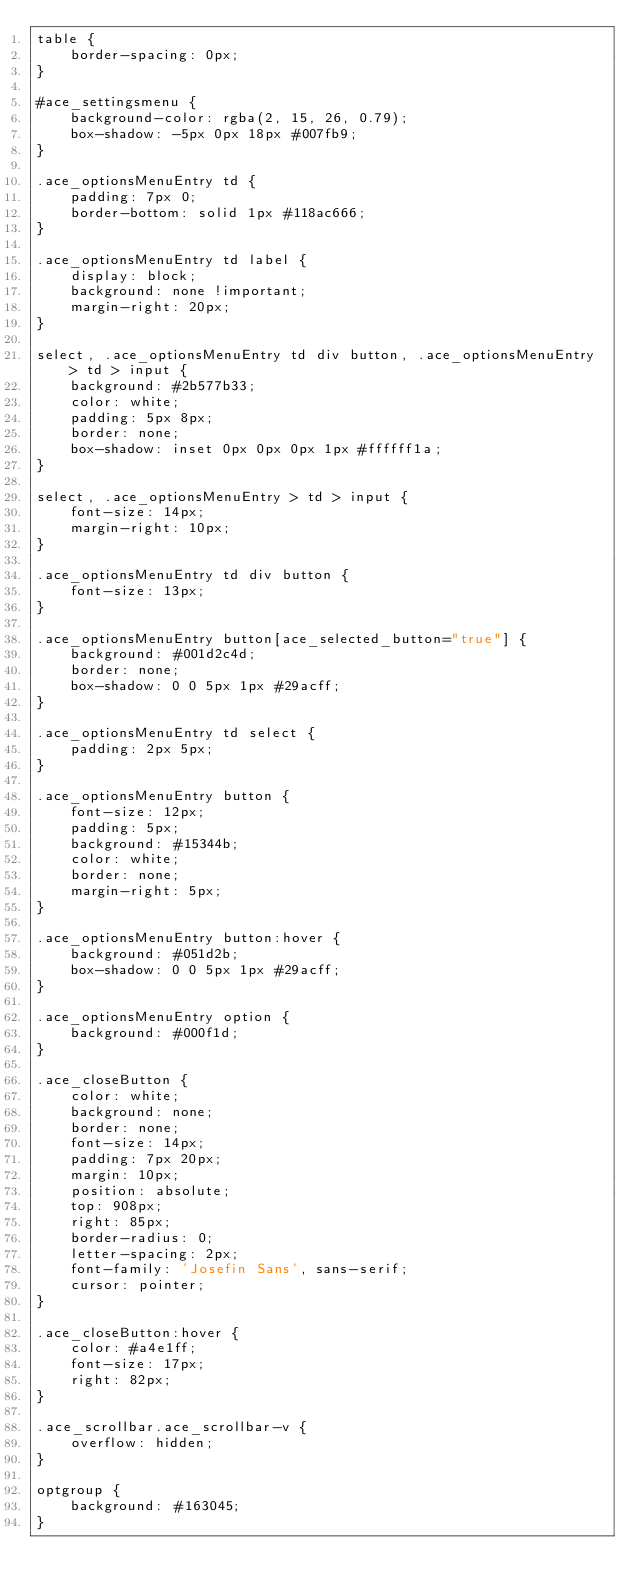<code> <loc_0><loc_0><loc_500><loc_500><_CSS_>table {
    border-spacing: 0px;
}

#ace_settingsmenu {
    background-color: rgba(2, 15, 26, 0.79);
    box-shadow: -5px 0px 18px #007fb9;
}

.ace_optionsMenuEntry td {
    padding: 7px 0;
    border-bottom: solid 1px #118ac666;
}

.ace_optionsMenuEntry td label {
    display: block;
    background: none !important;
    margin-right: 20px;
}

select, .ace_optionsMenuEntry td div button, .ace_optionsMenuEntry > td > input {
    background: #2b577b33;
    color: white;    
    padding: 5px 8px;
    border: none;
    box-shadow: inset 0px 0px 0px 1px #ffffff1a;
}

select, .ace_optionsMenuEntry > td > input {
    font-size: 14px;
    margin-right: 10px;
}

.ace_optionsMenuEntry td div button {
    font-size: 13px;
}

.ace_optionsMenuEntry button[ace_selected_button="true"] {
    background: #001d2c4d;
    border: none;
    box-shadow: 0 0 5px 1px #29acff;
}

.ace_optionsMenuEntry td select {
    padding: 2px 5px;
}

.ace_optionsMenuEntry button {
    font-size: 12px;
    padding: 5px;
    background: #15344b;
    color: white;
    border: none;
    margin-right: 5px;
}

.ace_optionsMenuEntry button:hover {
    background: #051d2b;
    box-shadow: 0 0 5px 1px #29acff;
}

.ace_optionsMenuEntry option {
    background: #000f1d;
}

.ace_closeButton {
    color: white;
    background: none;
    border: none;
    font-size: 14px;
    padding: 7px 20px;
    margin: 10px;
    position: absolute;
    top: 908px;
    right: 85px;
    border-radius: 0;
    letter-spacing: 2px;
    font-family: 'Josefin Sans', sans-serif;
    cursor: pointer;
}

.ace_closeButton:hover {
    color: #a4e1ff;
    font-size: 17px;
    right: 82px;
}

.ace_scrollbar.ace_scrollbar-v {
    overflow: hidden;
}

optgroup {
    background: #163045;
}

</code> 